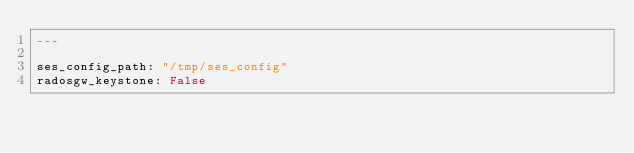<code> <loc_0><loc_0><loc_500><loc_500><_YAML_>---

ses_config_path: "/tmp/ses_config"
radosgw_keystone: False
</code> 